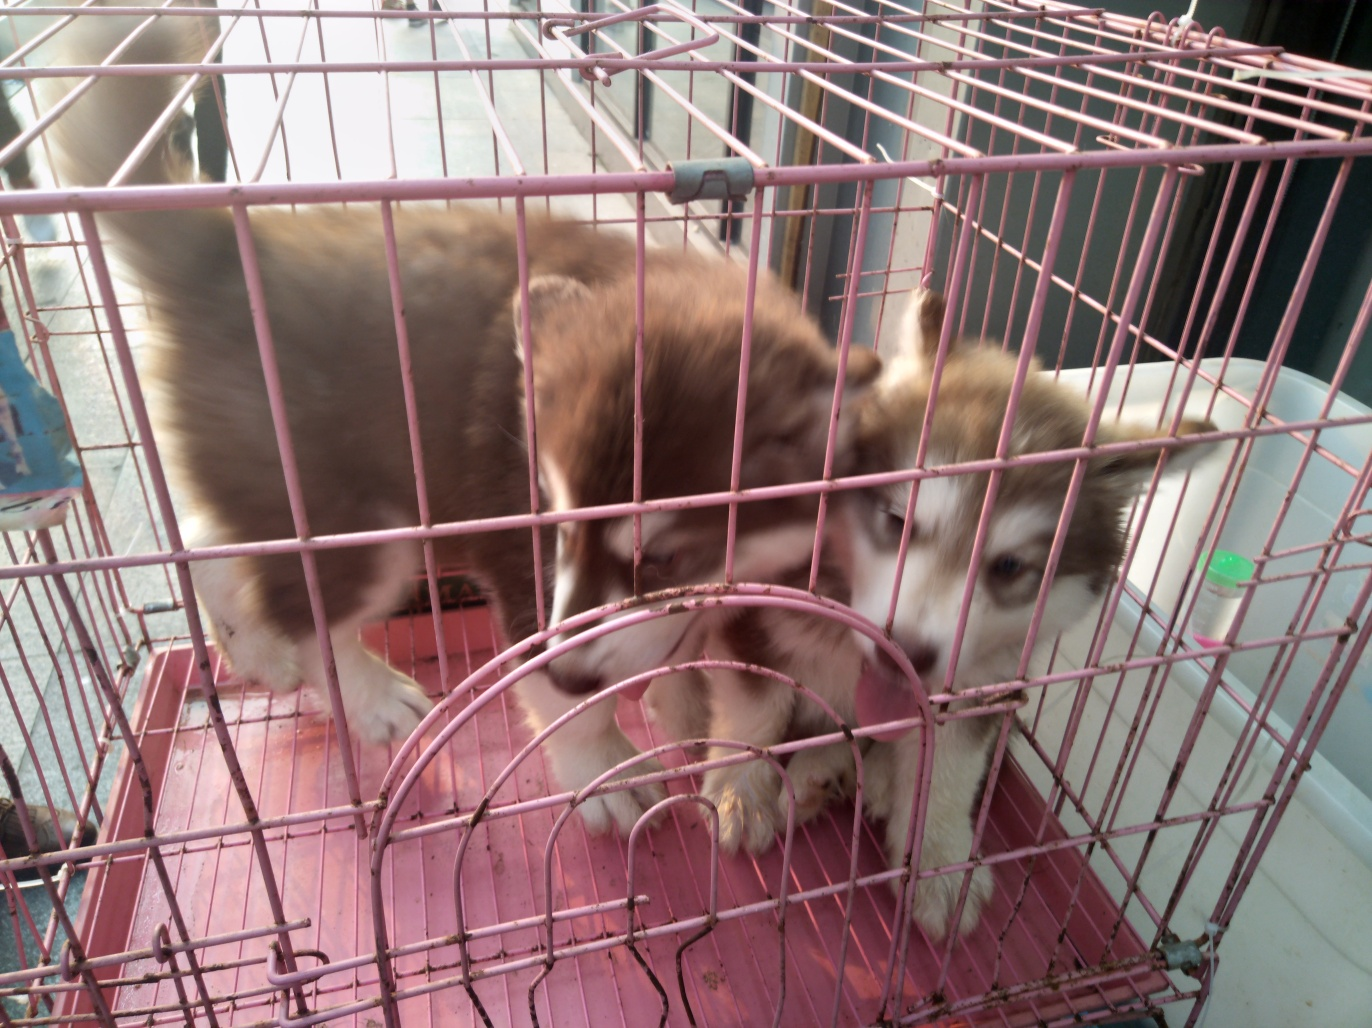Are the dogs in a suitable environment in this image? Based on the image, the dogs are confined in a cage that appears to be small relative to their size. A more suitable environment would provide ample space for movement, comfortable bedding, and enrichment opportunities consistent with their behavioral needs. 